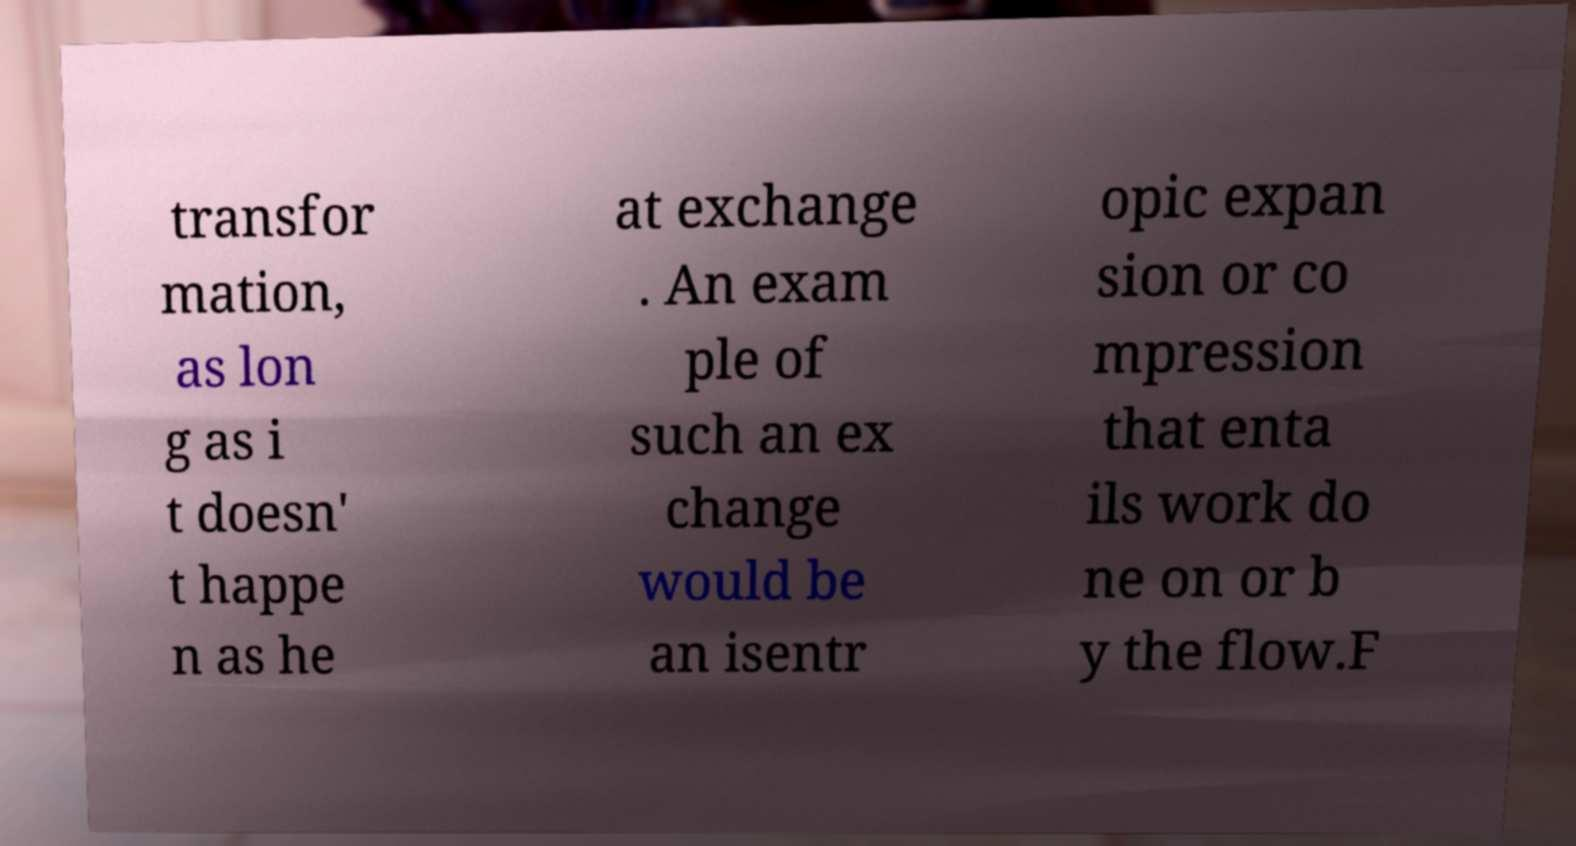There's text embedded in this image that I need extracted. Can you transcribe it verbatim? transfor mation, as lon g as i t doesn' t happe n as he at exchange . An exam ple of such an ex change would be an isentr opic expan sion or co mpression that enta ils work do ne on or b y the flow.F 